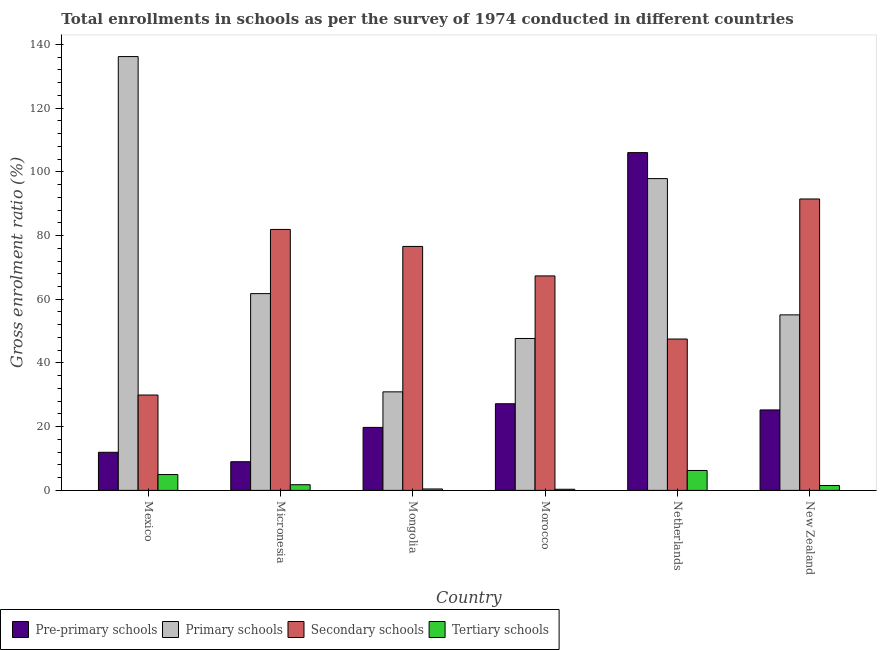How many groups of bars are there?
Keep it short and to the point. 6. Are the number of bars per tick equal to the number of legend labels?
Ensure brevity in your answer.  Yes. Are the number of bars on each tick of the X-axis equal?
Your answer should be compact. Yes. How many bars are there on the 1st tick from the right?
Give a very brief answer. 4. What is the label of the 4th group of bars from the left?
Ensure brevity in your answer.  Morocco. In how many cases, is the number of bars for a given country not equal to the number of legend labels?
Your answer should be compact. 0. What is the gross enrolment ratio in secondary schools in Morocco?
Ensure brevity in your answer.  67.33. Across all countries, what is the maximum gross enrolment ratio in pre-primary schools?
Provide a short and direct response. 106.03. Across all countries, what is the minimum gross enrolment ratio in pre-primary schools?
Make the answer very short. 9. In which country was the gross enrolment ratio in secondary schools minimum?
Your answer should be compact. Mexico. What is the total gross enrolment ratio in tertiary schools in the graph?
Provide a succinct answer. 15.34. What is the difference between the gross enrolment ratio in primary schools in Micronesia and that in Mongolia?
Ensure brevity in your answer.  30.83. What is the difference between the gross enrolment ratio in primary schools in Mexico and the gross enrolment ratio in secondary schools in New Zealand?
Offer a very short reply. 44.7. What is the average gross enrolment ratio in secondary schools per country?
Ensure brevity in your answer.  65.79. What is the difference between the gross enrolment ratio in pre-primary schools and gross enrolment ratio in secondary schools in New Zealand?
Your answer should be compact. -66.22. What is the ratio of the gross enrolment ratio in pre-primary schools in Mexico to that in Netherlands?
Offer a very short reply. 0.11. Is the gross enrolment ratio in secondary schools in Micronesia less than that in Mongolia?
Provide a succinct answer. No. What is the difference between the highest and the second highest gross enrolment ratio in primary schools?
Ensure brevity in your answer.  38.31. What is the difference between the highest and the lowest gross enrolment ratio in primary schools?
Offer a terse response. 105.24. In how many countries, is the gross enrolment ratio in primary schools greater than the average gross enrolment ratio in primary schools taken over all countries?
Provide a short and direct response. 2. Is it the case that in every country, the sum of the gross enrolment ratio in secondary schools and gross enrolment ratio in primary schools is greater than the sum of gross enrolment ratio in pre-primary schools and gross enrolment ratio in tertiary schools?
Make the answer very short. No. What does the 1st bar from the left in Netherlands represents?
Ensure brevity in your answer.  Pre-primary schools. What does the 3rd bar from the right in Mongolia represents?
Ensure brevity in your answer.  Primary schools. Is it the case that in every country, the sum of the gross enrolment ratio in pre-primary schools and gross enrolment ratio in primary schools is greater than the gross enrolment ratio in secondary schools?
Provide a short and direct response. No. How many countries are there in the graph?
Provide a short and direct response. 6. Are the values on the major ticks of Y-axis written in scientific E-notation?
Your response must be concise. No. Does the graph contain any zero values?
Keep it short and to the point. No. How many legend labels are there?
Offer a terse response. 4. How are the legend labels stacked?
Offer a very short reply. Horizontal. What is the title of the graph?
Give a very brief answer. Total enrollments in schools as per the survey of 1974 conducted in different countries. Does "Secondary" appear as one of the legend labels in the graph?
Make the answer very short. No. What is the label or title of the X-axis?
Your answer should be compact. Country. What is the label or title of the Y-axis?
Offer a very short reply. Gross enrolment ratio (%). What is the Gross enrolment ratio (%) of Pre-primary schools in Mexico?
Offer a very short reply. 11.96. What is the Gross enrolment ratio (%) of Primary schools in Mexico?
Provide a succinct answer. 136.18. What is the Gross enrolment ratio (%) in Secondary schools in Mexico?
Offer a terse response. 29.94. What is the Gross enrolment ratio (%) of Tertiary schools in Mexico?
Keep it short and to the point. 4.97. What is the Gross enrolment ratio (%) in Pre-primary schools in Micronesia?
Provide a succinct answer. 9. What is the Gross enrolment ratio (%) in Primary schools in Micronesia?
Offer a very short reply. 61.77. What is the Gross enrolment ratio (%) of Secondary schools in Micronesia?
Your answer should be very brief. 81.91. What is the Gross enrolment ratio (%) in Tertiary schools in Micronesia?
Provide a short and direct response. 1.78. What is the Gross enrolment ratio (%) of Pre-primary schools in Mongolia?
Ensure brevity in your answer.  19.77. What is the Gross enrolment ratio (%) in Primary schools in Mongolia?
Your answer should be very brief. 30.93. What is the Gross enrolment ratio (%) of Secondary schools in Mongolia?
Give a very brief answer. 76.58. What is the Gross enrolment ratio (%) in Tertiary schools in Mongolia?
Your answer should be compact. 0.45. What is the Gross enrolment ratio (%) in Pre-primary schools in Morocco?
Your answer should be compact. 27.2. What is the Gross enrolment ratio (%) of Primary schools in Morocco?
Keep it short and to the point. 47.68. What is the Gross enrolment ratio (%) in Secondary schools in Morocco?
Your answer should be compact. 67.33. What is the Gross enrolment ratio (%) of Tertiary schools in Morocco?
Provide a short and direct response. 0.35. What is the Gross enrolment ratio (%) of Pre-primary schools in Netherlands?
Offer a very short reply. 106.03. What is the Gross enrolment ratio (%) of Primary schools in Netherlands?
Give a very brief answer. 97.87. What is the Gross enrolment ratio (%) of Secondary schools in Netherlands?
Your response must be concise. 47.51. What is the Gross enrolment ratio (%) in Tertiary schools in Netherlands?
Give a very brief answer. 6.25. What is the Gross enrolment ratio (%) in Pre-primary schools in New Zealand?
Your answer should be very brief. 25.25. What is the Gross enrolment ratio (%) of Primary schools in New Zealand?
Provide a succinct answer. 55.09. What is the Gross enrolment ratio (%) in Secondary schools in New Zealand?
Offer a terse response. 91.47. What is the Gross enrolment ratio (%) of Tertiary schools in New Zealand?
Make the answer very short. 1.54. Across all countries, what is the maximum Gross enrolment ratio (%) of Pre-primary schools?
Your response must be concise. 106.03. Across all countries, what is the maximum Gross enrolment ratio (%) of Primary schools?
Make the answer very short. 136.18. Across all countries, what is the maximum Gross enrolment ratio (%) in Secondary schools?
Provide a short and direct response. 91.47. Across all countries, what is the maximum Gross enrolment ratio (%) of Tertiary schools?
Offer a very short reply. 6.25. Across all countries, what is the minimum Gross enrolment ratio (%) of Pre-primary schools?
Your answer should be very brief. 9. Across all countries, what is the minimum Gross enrolment ratio (%) of Primary schools?
Ensure brevity in your answer.  30.93. Across all countries, what is the minimum Gross enrolment ratio (%) of Secondary schools?
Give a very brief answer. 29.94. Across all countries, what is the minimum Gross enrolment ratio (%) of Tertiary schools?
Make the answer very short. 0.35. What is the total Gross enrolment ratio (%) in Pre-primary schools in the graph?
Offer a terse response. 199.2. What is the total Gross enrolment ratio (%) in Primary schools in the graph?
Provide a succinct answer. 429.53. What is the total Gross enrolment ratio (%) of Secondary schools in the graph?
Offer a very short reply. 394.75. What is the total Gross enrolment ratio (%) in Tertiary schools in the graph?
Ensure brevity in your answer.  15.34. What is the difference between the Gross enrolment ratio (%) of Pre-primary schools in Mexico and that in Micronesia?
Your response must be concise. 2.96. What is the difference between the Gross enrolment ratio (%) of Primary schools in Mexico and that in Micronesia?
Offer a very short reply. 74.41. What is the difference between the Gross enrolment ratio (%) of Secondary schools in Mexico and that in Micronesia?
Give a very brief answer. -51.98. What is the difference between the Gross enrolment ratio (%) of Tertiary schools in Mexico and that in Micronesia?
Provide a succinct answer. 3.19. What is the difference between the Gross enrolment ratio (%) of Pre-primary schools in Mexico and that in Mongolia?
Keep it short and to the point. -7.81. What is the difference between the Gross enrolment ratio (%) of Primary schools in Mexico and that in Mongolia?
Ensure brevity in your answer.  105.24. What is the difference between the Gross enrolment ratio (%) of Secondary schools in Mexico and that in Mongolia?
Your answer should be compact. -46.64. What is the difference between the Gross enrolment ratio (%) in Tertiary schools in Mexico and that in Mongolia?
Offer a very short reply. 4.53. What is the difference between the Gross enrolment ratio (%) in Pre-primary schools in Mexico and that in Morocco?
Give a very brief answer. -15.24. What is the difference between the Gross enrolment ratio (%) of Primary schools in Mexico and that in Morocco?
Your answer should be compact. 88.49. What is the difference between the Gross enrolment ratio (%) in Secondary schools in Mexico and that in Morocco?
Your response must be concise. -37.39. What is the difference between the Gross enrolment ratio (%) of Tertiary schools in Mexico and that in Morocco?
Make the answer very short. 4.62. What is the difference between the Gross enrolment ratio (%) of Pre-primary schools in Mexico and that in Netherlands?
Make the answer very short. -94.07. What is the difference between the Gross enrolment ratio (%) in Primary schools in Mexico and that in Netherlands?
Your answer should be very brief. 38.31. What is the difference between the Gross enrolment ratio (%) of Secondary schools in Mexico and that in Netherlands?
Offer a terse response. -17.58. What is the difference between the Gross enrolment ratio (%) of Tertiary schools in Mexico and that in Netherlands?
Give a very brief answer. -1.28. What is the difference between the Gross enrolment ratio (%) of Pre-primary schools in Mexico and that in New Zealand?
Give a very brief answer. -13.3. What is the difference between the Gross enrolment ratio (%) in Primary schools in Mexico and that in New Zealand?
Your answer should be compact. 81.08. What is the difference between the Gross enrolment ratio (%) of Secondary schools in Mexico and that in New Zealand?
Offer a terse response. -61.54. What is the difference between the Gross enrolment ratio (%) of Tertiary schools in Mexico and that in New Zealand?
Offer a very short reply. 3.44. What is the difference between the Gross enrolment ratio (%) in Pre-primary schools in Micronesia and that in Mongolia?
Make the answer very short. -10.77. What is the difference between the Gross enrolment ratio (%) in Primary schools in Micronesia and that in Mongolia?
Keep it short and to the point. 30.83. What is the difference between the Gross enrolment ratio (%) of Secondary schools in Micronesia and that in Mongolia?
Give a very brief answer. 5.33. What is the difference between the Gross enrolment ratio (%) in Tertiary schools in Micronesia and that in Mongolia?
Make the answer very short. 1.33. What is the difference between the Gross enrolment ratio (%) in Pre-primary schools in Micronesia and that in Morocco?
Your response must be concise. -18.2. What is the difference between the Gross enrolment ratio (%) in Primary schools in Micronesia and that in Morocco?
Your answer should be very brief. 14.08. What is the difference between the Gross enrolment ratio (%) of Secondary schools in Micronesia and that in Morocco?
Provide a succinct answer. 14.59. What is the difference between the Gross enrolment ratio (%) of Tertiary schools in Micronesia and that in Morocco?
Your answer should be compact. 1.43. What is the difference between the Gross enrolment ratio (%) in Pre-primary schools in Micronesia and that in Netherlands?
Provide a short and direct response. -97.03. What is the difference between the Gross enrolment ratio (%) of Primary schools in Micronesia and that in Netherlands?
Give a very brief answer. -36.1. What is the difference between the Gross enrolment ratio (%) in Secondary schools in Micronesia and that in Netherlands?
Offer a terse response. 34.4. What is the difference between the Gross enrolment ratio (%) of Tertiary schools in Micronesia and that in Netherlands?
Offer a very short reply. -4.47. What is the difference between the Gross enrolment ratio (%) of Pre-primary schools in Micronesia and that in New Zealand?
Offer a terse response. -16.25. What is the difference between the Gross enrolment ratio (%) in Primary schools in Micronesia and that in New Zealand?
Keep it short and to the point. 6.67. What is the difference between the Gross enrolment ratio (%) of Secondary schools in Micronesia and that in New Zealand?
Offer a very short reply. -9.56. What is the difference between the Gross enrolment ratio (%) of Tertiary schools in Micronesia and that in New Zealand?
Ensure brevity in your answer.  0.24. What is the difference between the Gross enrolment ratio (%) of Pre-primary schools in Mongolia and that in Morocco?
Give a very brief answer. -7.42. What is the difference between the Gross enrolment ratio (%) in Primary schools in Mongolia and that in Morocco?
Make the answer very short. -16.75. What is the difference between the Gross enrolment ratio (%) of Secondary schools in Mongolia and that in Morocco?
Offer a terse response. 9.26. What is the difference between the Gross enrolment ratio (%) of Tertiary schools in Mongolia and that in Morocco?
Provide a short and direct response. 0.09. What is the difference between the Gross enrolment ratio (%) of Pre-primary schools in Mongolia and that in Netherlands?
Offer a terse response. -86.26. What is the difference between the Gross enrolment ratio (%) in Primary schools in Mongolia and that in Netherlands?
Provide a short and direct response. -66.94. What is the difference between the Gross enrolment ratio (%) in Secondary schools in Mongolia and that in Netherlands?
Provide a succinct answer. 29.07. What is the difference between the Gross enrolment ratio (%) of Tertiary schools in Mongolia and that in Netherlands?
Give a very brief answer. -5.8. What is the difference between the Gross enrolment ratio (%) in Pre-primary schools in Mongolia and that in New Zealand?
Make the answer very short. -5.48. What is the difference between the Gross enrolment ratio (%) of Primary schools in Mongolia and that in New Zealand?
Your answer should be compact. -24.16. What is the difference between the Gross enrolment ratio (%) in Secondary schools in Mongolia and that in New Zealand?
Offer a very short reply. -14.89. What is the difference between the Gross enrolment ratio (%) of Tertiary schools in Mongolia and that in New Zealand?
Give a very brief answer. -1.09. What is the difference between the Gross enrolment ratio (%) of Pre-primary schools in Morocco and that in Netherlands?
Your answer should be very brief. -78.83. What is the difference between the Gross enrolment ratio (%) of Primary schools in Morocco and that in Netherlands?
Provide a short and direct response. -50.18. What is the difference between the Gross enrolment ratio (%) of Secondary schools in Morocco and that in Netherlands?
Your answer should be very brief. 19.81. What is the difference between the Gross enrolment ratio (%) of Tertiary schools in Morocco and that in Netherlands?
Give a very brief answer. -5.9. What is the difference between the Gross enrolment ratio (%) in Pre-primary schools in Morocco and that in New Zealand?
Provide a succinct answer. 1.94. What is the difference between the Gross enrolment ratio (%) of Primary schools in Morocco and that in New Zealand?
Provide a succinct answer. -7.41. What is the difference between the Gross enrolment ratio (%) of Secondary schools in Morocco and that in New Zealand?
Keep it short and to the point. -24.15. What is the difference between the Gross enrolment ratio (%) in Tertiary schools in Morocco and that in New Zealand?
Make the answer very short. -1.18. What is the difference between the Gross enrolment ratio (%) of Pre-primary schools in Netherlands and that in New Zealand?
Give a very brief answer. 80.77. What is the difference between the Gross enrolment ratio (%) in Primary schools in Netherlands and that in New Zealand?
Provide a succinct answer. 42.77. What is the difference between the Gross enrolment ratio (%) of Secondary schools in Netherlands and that in New Zealand?
Give a very brief answer. -43.96. What is the difference between the Gross enrolment ratio (%) in Tertiary schools in Netherlands and that in New Zealand?
Offer a terse response. 4.71. What is the difference between the Gross enrolment ratio (%) of Pre-primary schools in Mexico and the Gross enrolment ratio (%) of Primary schools in Micronesia?
Your response must be concise. -49.81. What is the difference between the Gross enrolment ratio (%) of Pre-primary schools in Mexico and the Gross enrolment ratio (%) of Secondary schools in Micronesia?
Make the answer very short. -69.96. What is the difference between the Gross enrolment ratio (%) in Pre-primary schools in Mexico and the Gross enrolment ratio (%) in Tertiary schools in Micronesia?
Offer a very short reply. 10.18. What is the difference between the Gross enrolment ratio (%) of Primary schools in Mexico and the Gross enrolment ratio (%) of Secondary schools in Micronesia?
Make the answer very short. 54.26. What is the difference between the Gross enrolment ratio (%) of Primary schools in Mexico and the Gross enrolment ratio (%) of Tertiary schools in Micronesia?
Your answer should be compact. 134.4. What is the difference between the Gross enrolment ratio (%) of Secondary schools in Mexico and the Gross enrolment ratio (%) of Tertiary schools in Micronesia?
Provide a succinct answer. 28.16. What is the difference between the Gross enrolment ratio (%) in Pre-primary schools in Mexico and the Gross enrolment ratio (%) in Primary schools in Mongolia?
Keep it short and to the point. -18.98. What is the difference between the Gross enrolment ratio (%) of Pre-primary schools in Mexico and the Gross enrolment ratio (%) of Secondary schools in Mongolia?
Your answer should be compact. -64.62. What is the difference between the Gross enrolment ratio (%) in Pre-primary schools in Mexico and the Gross enrolment ratio (%) in Tertiary schools in Mongolia?
Your answer should be very brief. 11.51. What is the difference between the Gross enrolment ratio (%) in Primary schools in Mexico and the Gross enrolment ratio (%) in Secondary schools in Mongolia?
Keep it short and to the point. 59.6. What is the difference between the Gross enrolment ratio (%) in Primary schools in Mexico and the Gross enrolment ratio (%) in Tertiary schools in Mongolia?
Ensure brevity in your answer.  135.73. What is the difference between the Gross enrolment ratio (%) of Secondary schools in Mexico and the Gross enrolment ratio (%) of Tertiary schools in Mongolia?
Provide a short and direct response. 29.49. What is the difference between the Gross enrolment ratio (%) of Pre-primary schools in Mexico and the Gross enrolment ratio (%) of Primary schools in Morocco?
Provide a short and direct response. -35.73. What is the difference between the Gross enrolment ratio (%) of Pre-primary schools in Mexico and the Gross enrolment ratio (%) of Secondary schools in Morocco?
Your answer should be very brief. -55.37. What is the difference between the Gross enrolment ratio (%) in Pre-primary schools in Mexico and the Gross enrolment ratio (%) in Tertiary schools in Morocco?
Your answer should be very brief. 11.6. What is the difference between the Gross enrolment ratio (%) of Primary schools in Mexico and the Gross enrolment ratio (%) of Secondary schools in Morocco?
Offer a terse response. 68.85. What is the difference between the Gross enrolment ratio (%) of Primary schools in Mexico and the Gross enrolment ratio (%) of Tertiary schools in Morocco?
Keep it short and to the point. 135.83. What is the difference between the Gross enrolment ratio (%) in Secondary schools in Mexico and the Gross enrolment ratio (%) in Tertiary schools in Morocco?
Provide a succinct answer. 29.58. What is the difference between the Gross enrolment ratio (%) in Pre-primary schools in Mexico and the Gross enrolment ratio (%) in Primary schools in Netherlands?
Ensure brevity in your answer.  -85.91. What is the difference between the Gross enrolment ratio (%) of Pre-primary schools in Mexico and the Gross enrolment ratio (%) of Secondary schools in Netherlands?
Make the answer very short. -35.56. What is the difference between the Gross enrolment ratio (%) of Pre-primary schools in Mexico and the Gross enrolment ratio (%) of Tertiary schools in Netherlands?
Provide a succinct answer. 5.71. What is the difference between the Gross enrolment ratio (%) in Primary schools in Mexico and the Gross enrolment ratio (%) in Secondary schools in Netherlands?
Your answer should be very brief. 88.66. What is the difference between the Gross enrolment ratio (%) of Primary schools in Mexico and the Gross enrolment ratio (%) of Tertiary schools in Netherlands?
Make the answer very short. 129.93. What is the difference between the Gross enrolment ratio (%) of Secondary schools in Mexico and the Gross enrolment ratio (%) of Tertiary schools in Netherlands?
Your answer should be compact. 23.69. What is the difference between the Gross enrolment ratio (%) in Pre-primary schools in Mexico and the Gross enrolment ratio (%) in Primary schools in New Zealand?
Your answer should be compact. -43.14. What is the difference between the Gross enrolment ratio (%) of Pre-primary schools in Mexico and the Gross enrolment ratio (%) of Secondary schools in New Zealand?
Your response must be concise. -79.52. What is the difference between the Gross enrolment ratio (%) in Pre-primary schools in Mexico and the Gross enrolment ratio (%) in Tertiary schools in New Zealand?
Ensure brevity in your answer.  10.42. What is the difference between the Gross enrolment ratio (%) of Primary schools in Mexico and the Gross enrolment ratio (%) of Secondary schools in New Zealand?
Ensure brevity in your answer.  44.7. What is the difference between the Gross enrolment ratio (%) in Primary schools in Mexico and the Gross enrolment ratio (%) in Tertiary schools in New Zealand?
Make the answer very short. 134.64. What is the difference between the Gross enrolment ratio (%) in Secondary schools in Mexico and the Gross enrolment ratio (%) in Tertiary schools in New Zealand?
Offer a terse response. 28.4. What is the difference between the Gross enrolment ratio (%) of Pre-primary schools in Micronesia and the Gross enrolment ratio (%) of Primary schools in Mongolia?
Provide a short and direct response. -21.93. What is the difference between the Gross enrolment ratio (%) of Pre-primary schools in Micronesia and the Gross enrolment ratio (%) of Secondary schools in Mongolia?
Your answer should be compact. -67.58. What is the difference between the Gross enrolment ratio (%) of Pre-primary schools in Micronesia and the Gross enrolment ratio (%) of Tertiary schools in Mongolia?
Offer a very short reply. 8.55. What is the difference between the Gross enrolment ratio (%) of Primary schools in Micronesia and the Gross enrolment ratio (%) of Secondary schools in Mongolia?
Your answer should be very brief. -14.82. What is the difference between the Gross enrolment ratio (%) of Primary schools in Micronesia and the Gross enrolment ratio (%) of Tertiary schools in Mongolia?
Your answer should be compact. 61.32. What is the difference between the Gross enrolment ratio (%) of Secondary schools in Micronesia and the Gross enrolment ratio (%) of Tertiary schools in Mongolia?
Your answer should be very brief. 81.47. What is the difference between the Gross enrolment ratio (%) of Pre-primary schools in Micronesia and the Gross enrolment ratio (%) of Primary schools in Morocco?
Offer a very short reply. -38.69. What is the difference between the Gross enrolment ratio (%) in Pre-primary schools in Micronesia and the Gross enrolment ratio (%) in Secondary schools in Morocco?
Offer a very short reply. -58.33. What is the difference between the Gross enrolment ratio (%) in Pre-primary schools in Micronesia and the Gross enrolment ratio (%) in Tertiary schools in Morocco?
Make the answer very short. 8.65. What is the difference between the Gross enrolment ratio (%) in Primary schools in Micronesia and the Gross enrolment ratio (%) in Secondary schools in Morocco?
Give a very brief answer. -5.56. What is the difference between the Gross enrolment ratio (%) in Primary schools in Micronesia and the Gross enrolment ratio (%) in Tertiary schools in Morocco?
Keep it short and to the point. 61.41. What is the difference between the Gross enrolment ratio (%) of Secondary schools in Micronesia and the Gross enrolment ratio (%) of Tertiary schools in Morocco?
Offer a terse response. 81.56. What is the difference between the Gross enrolment ratio (%) in Pre-primary schools in Micronesia and the Gross enrolment ratio (%) in Primary schools in Netherlands?
Make the answer very short. -88.87. What is the difference between the Gross enrolment ratio (%) of Pre-primary schools in Micronesia and the Gross enrolment ratio (%) of Secondary schools in Netherlands?
Make the answer very short. -38.51. What is the difference between the Gross enrolment ratio (%) in Pre-primary schools in Micronesia and the Gross enrolment ratio (%) in Tertiary schools in Netherlands?
Give a very brief answer. 2.75. What is the difference between the Gross enrolment ratio (%) in Primary schools in Micronesia and the Gross enrolment ratio (%) in Secondary schools in Netherlands?
Your answer should be compact. 14.25. What is the difference between the Gross enrolment ratio (%) in Primary schools in Micronesia and the Gross enrolment ratio (%) in Tertiary schools in Netherlands?
Your answer should be compact. 55.51. What is the difference between the Gross enrolment ratio (%) of Secondary schools in Micronesia and the Gross enrolment ratio (%) of Tertiary schools in Netherlands?
Offer a very short reply. 75.66. What is the difference between the Gross enrolment ratio (%) in Pre-primary schools in Micronesia and the Gross enrolment ratio (%) in Primary schools in New Zealand?
Give a very brief answer. -46.1. What is the difference between the Gross enrolment ratio (%) of Pre-primary schools in Micronesia and the Gross enrolment ratio (%) of Secondary schools in New Zealand?
Provide a short and direct response. -82.47. What is the difference between the Gross enrolment ratio (%) of Pre-primary schools in Micronesia and the Gross enrolment ratio (%) of Tertiary schools in New Zealand?
Ensure brevity in your answer.  7.46. What is the difference between the Gross enrolment ratio (%) in Primary schools in Micronesia and the Gross enrolment ratio (%) in Secondary schools in New Zealand?
Your response must be concise. -29.71. What is the difference between the Gross enrolment ratio (%) of Primary schools in Micronesia and the Gross enrolment ratio (%) of Tertiary schools in New Zealand?
Provide a short and direct response. 60.23. What is the difference between the Gross enrolment ratio (%) in Secondary schools in Micronesia and the Gross enrolment ratio (%) in Tertiary schools in New Zealand?
Give a very brief answer. 80.38. What is the difference between the Gross enrolment ratio (%) in Pre-primary schools in Mongolia and the Gross enrolment ratio (%) in Primary schools in Morocco?
Provide a short and direct response. -27.91. What is the difference between the Gross enrolment ratio (%) of Pre-primary schools in Mongolia and the Gross enrolment ratio (%) of Secondary schools in Morocco?
Your answer should be very brief. -47.55. What is the difference between the Gross enrolment ratio (%) in Pre-primary schools in Mongolia and the Gross enrolment ratio (%) in Tertiary schools in Morocco?
Your answer should be compact. 19.42. What is the difference between the Gross enrolment ratio (%) of Primary schools in Mongolia and the Gross enrolment ratio (%) of Secondary schools in Morocco?
Offer a very short reply. -36.39. What is the difference between the Gross enrolment ratio (%) in Primary schools in Mongolia and the Gross enrolment ratio (%) in Tertiary schools in Morocco?
Offer a terse response. 30.58. What is the difference between the Gross enrolment ratio (%) in Secondary schools in Mongolia and the Gross enrolment ratio (%) in Tertiary schools in Morocco?
Give a very brief answer. 76.23. What is the difference between the Gross enrolment ratio (%) of Pre-primary schools in Mongolia and the Gross enrolment ratio (%) of Primary schools in Netherlands?
Your answer should be compact. -78.1. What is the difference between the Gross enrolment ratio (%) of Pre-primary schools in Mongolia and the Gross enrolment ratio (%) of Secondary schools in Netherlands?
Offer a terse response. -27.74. What is the difference between the Gross enrolment ratio (%) in Pre-primary schools in Mongolia and the Gross enrolment ratio (%) in Tertiary schools in Netherlands?
Offer a very short reply. 13.52. What is the difference between the Gross enrolment ratio (%) of Primary schools in Mongolia and the Gross enrolment ratio (%) of Secondary schools in Netherlands?
Provide a succinct answer. -16.58. What is the difference between the Gross enrolment ratio (%) in Primary schools in Mongolia and the Gross enrolment ratio (%) in Tertiary schools in Netherlands?
Provide a short and direct response. 24.68. What is the difference between the Gross enrolment ratio (%) of Secondary schools in Mongolia and the Gross enrolment ratio (%) of Tertiary schools in Netherlands?
Your answer should be compact. 70.33. What is the difference between the Gross enrolment ratio (%) of Pre-primary schools in Mongolia and the Gross enrolment ratio (%) of Primary schools in New Zealand?
Your answer should be very brief. -35.32. What is the difference between the Gross enrolment ratio (%) in Pre-primary schools in Mongolia and the Gross enrolment ratio (%) in Secondary schools in New Zealand?
Your answer should be very brief. -71.7. What is the difference between the Gross enrolment ratio (%) of Pre-primary schools in Mongolia and the Gross enrolment ratio (%) of Tertiary schools in New Zealand?
Ensure brevity in your answer.  18.23. What is the difference between the Gross enrolment ratio (%) of Primary schools in Mongolia and the Gross enrolment ratio (%) of Secondary schools in New Zealand?
Give a very brief answer. -60.54. What is the difference between the Gross enrolment ratio (%) in Primary schools in Mongolia and the Gross enrolment ratio (%) in Tertiary schools in New Zealand?
Your answer should be very brief. 29.4. What is the difference between the Gross enrolment ratio (%) in Secondary schools in Mongolia and the Gross enrolment ratio (%) in Tertiary schools in New Zealand?
Offer a terse response. 75.04. What is the difference between the Gross enrolment ratio (%) in Pre-primary schools in Morocco and the Gross enrolment ratio (%) in Primary schools in Netherlands?
Provide a succinct answer. -70.67. What is the difference between the Gross enrolment ratio (%) of Pre-primary schools in Morocco and the Gross enrolment ratio (%) of Secondary schools in Netherlands?
Make the answer very short. -20.32. What is the difference between the Gross enrolment ratio (%) in Pre-primary schools in Morocco and the Gross enrolment ratio (%) in Tertiary schools in Netherlands?
Make the answer very short. 20.94. What is the difference between the Gross enrolment ratio (%) of Primary schools in Morocco and the Gross enrolment ratio (%) of Secondary schools in Netherlands?
Offer a terse response. 0.17. What is the difference between the Gross enrolment ratio (%) in Primary schools in Morocco and the Gross enrolment ratio (%) in Tertiary schools in Netherlands?
Offer a terse response. 41.43. What is the difference between the Gross enrolment ratio (%) in Secondary schools in Morocco and the Gross enrolment ratio (%) in Tertiary schools in Netherlands?
Give a very brief answer. 61.07. What is the difference between the Gross enrolment ratio (%) of Pre-primary schools in Morocco and the Gross enrolment ratio (%) of Primary schools in New Zealand?
Give a very brief answer. -27.9. What is the difference between the Gross enrolment ratio (%) in Pre-primary schools in Morocco and the Gross enrolment ratio (%) in Secondary schools in New Zealand?
Keep it short and to the point. -64.28. What is the difference between the Gross enrolment ratio (%) in Pre-primary schools in Morocco and the Gross enrolment ratio (%) in Tertiary schools in New Zealand?
Your response must be concise. 25.66. What is the difference between the Gross enrolment ratio (%) in Primary schools in Morocco and the Gross enrolment ratio (%) in Secondary schools in New Zealand?
Keep it short and to the point. -43.79. What is the difference between the Gross enrolment ratio (%) of Primary schools in Morocco and the Gross enrolment ratio (%) of Tertiary schools in New Zealand?
Provide a short and direct response. 46.15. What is the difference between the Gross enrolment ratio (%) in Secondary schools in Morocco and the Gross enrolment ratio (%) in Tertiary schools in New Zealand?
Your answer should be very brief. 65.79. What is the difference between the Gross enrolment ratio (%) in Pre-primary schools in Netherlands and the Gross enrolment ratio (%) in Primary schools in New Zealand?
Ensure brevity in your answer.  50.93. What is the difference between the Gross enrolment ratio (%) in Pre-primary schools in Netherlands and the Gross enrolment ratio (%) in Secondary schools in New Zealand?
Give a very brief answer. 14.55. What is the difference between the Gross enrolment ratio (%) of Pre-primary schools in Netherlands and the Gross enrolment ratio (%) of Tertiary schools in New Zealand?
Ensure brevity in your answer.  104.49. What is the difference between the Gross enrolment ratio (%) of Primary schools in Netherlands and the Gross enrolment ratio (%) of Secondary schools in New Zealand?
Provide a succinct answer. 6.4. What is the difference between the Gross enrolment ratio (%) of Primary schools in Netherlands and the Gross enrolment ratio (%) of Tertiary schools in New Zealand?
Provide a short and direct response. 96.33. What is the difference between the Gross enrolment ratio (%) in Secondary schools in Netherlands and the Gross enrolment ratio (%) in Tertiary schools in New Zealand?
Ensure brevity in your answer.  45.98. What is the average Gross enrolment ratio (%) in Pre-primary schools per country?
Give a very brief answer. 33.2. What is the average Gross enrolment ratio (%) of Primary schools per country?
Keep it short and to the point. 71.59. What is the average Gross enrolment ratio (%) in Secondary schools per country?
Your answer should be very brief. 65.79. What is the average Gross enrolment ratio (%) in Tertiary schools per country?
Provide a succinct answer. 2.56. What is the difference between the Gross enrolment ratio (%) of Pre-primary schools and Gross enrolment ratio (%) of Primary schools in Mexico?
Give a very brief answer. -124.22. What is the difference between the Gross enrolment ratio (%) of Pre-primary schools and Gross enrolment ratio (%) of Secondary schools in Mexico?
Provide a succinct answer. -17.98. What is the difference between the Gross enrolment ratio (%) of Pre-primary schools and Gross enrolment ratio (%) of Tertiary schools in Mexico?
Ensure brevity in your answer.  6.98. What is the difference between the Gross enrolment ratio (%) in Primary schools and Gross enrolment ratio (%) in Secondary schools in Mexico?
Make the answer very short. 106.24. What is the difference between the Gross enrolment ratio (%) in Primary schools and Gross enrolment ratio (%) in Tertiary schools in Mexico?
Give a very brief answer. 131.21. What is the difference between the Gross enrolment ratio (%) in Secondary schools and Gross enrolment ratio (%) in Tertiary schools in Mexico?
Keep it short and to the point. 24.96. What is the difference between the Gross enrolment ratio (%) in Pre-primary schools and Gross enrolment ratio (%) in Primary schools in Micronesia?
Provide a short and direct response. -52.77. What is the difference between the Gross enrolment ratio (%) of Pre-primary schools and Gross enrolment ratio (%) of Secondary schools in Micronesia?
Provide a short and direct response. -72.92. What is the difference between the Gross enrolment ratio (%) of Pre-primary schools and Gross enrolment ratio (%) of Tertiary schools in Micronesia?
Offer a very short reply. 7.22. What is the difference between the Gross enrolment ratio (%) in Primary schools and Gross enrolment ratio (%) in Secondary schools in Micronesia?
Your answer should be compact. -20.15. What is the difference between the Gross enrolment ratio (%) of Primary schools and Gross enrolment ratio (%) of Tertiary schools in Micronesia?
Make the answer very short. 59.98. What is the difference between the Gross enrolment ratio (%) in Secondary schools and Gross enrolment ratio (%) in Tertiary schools in Micronesia?
Offer a terse response. 80.13. What is the difference between the Gross enrolment ratio (%) in Pre-primary schools and Gross enrolment ratio (%) in Primary schools in Mongolia?
Give a very brief answer. -11.16. What is the difference between the Gross enrolment ratio (%) of Pre-primary schools and Gross enrolment ratio (%) of Secondary schools in Mongolia?
Provide a succinct answer. -56.81. What is the difference between the Gross enrolment ratio (%) in Pre-primary schools and Gross enrolment ratio (%) in Tertiary schools in Mongolia?
Give a very brief answer. 19.32. What is the difference between the Gross enrolment ratio (%) in Primary schools and Gross enrolment ratio (%) in Secondary schools in Mongolia?
Provide a short and direct response. -45.65. What is the difference between the Gross enrolment ratio (%) of Primary schools and Gross enrolment ratio (%) of Tertiary schools in Mongolia?
Provide a short and direct response. 30.49. What is the difference between the Gross enrolment ratio (%) of Secondary schools and Gross enrolment ratio (%) of Tertiary schools in Mongolia?
Ensure brevity in your answer.  76.13. What is the difference between the Gross enrolment ratio (%) in Pre-primary schools and Gross enrolment ratio (%) in Primary schools in Morocco?
Make the answer very short. -20.49. What is the difference between the Gross enrolment ratio (%) of Pre-primary schools and Gross enrolment ratio (%) of Secondary schools in Morocco?
Your answer should be very brief. -40.13. What is the difference between the Gross enrolment ratio (%) of Pre-primary schools and Gross enrolment ratio (%) of Tertiary schools in Morocco?
Provide a short and direct response. 26.84. What is the difference between the Gross enrolment ratio (%) of Primary schools and Gross enrolment ratio (%) of Secondary schools in Morocco?
Your answer should be compact. -19.64. What is the difference between the Gross enrolment ratio (%) of Primary schools and Gross enrolment ratio (%) of Tertiary schools in Morocco?
Provide a succinct answer. 47.33. What is the difference between the Gross enrolment ratio (%) in Secondary schools and Gross enrolment ratio (%) in Tertiary schools in Morocco?
Your response must be concise. 66.97. What is the difference between the Gross enrolment ratio (%) in Pre-primary schools and Gross enrolment ratio (%) in Primary schools in Netherlands?
Your answer should be very brief. 8.16. What is the difference between the Gross enrolment ratio (%) of Pre-primary schools and Gross enrolment ratio (%) of Secondary schools in Netherlands?
Keep it short and to the point. 58.51. What is the difference between the Gross enrolment ratio (%) in Pre-primary schools and Gross enrolment ratio (%) in Tertiary schools in Netherlands?
Your response must be concise. 99.78. What is the difference between the Gross enrolment ratio (%) in Primary schools and Gross enrolment ratio (%) in Secondary schools in Netherlands?
Keep it short and to the point. 50.36. What is the difference between the Gross enrolment ratio (%) in Primary schools and Gross enrolment ratio (%) in Tertiary schools in Netherlands?
Your answer should be compact. 91.62. What is the difference between the Gross enrolment ratio (%) of Secondary schools and Gross enrolment ratio (%) of Tertiary schools in Netherlands?
Provide a succinct answer. 41.26. What is the difference between the Gross enrolment ratio (%) of Pre-primary schools and Gross enrolment ratio (%) of Primary schools in New Zealand?
Your answer should be compact. -29.84. What is the difference between the Gross enrolment ratio (%) in Pre-primary schools and Gross enrolment ratio (%) in Secondary schools in New Zealand?
Give a very brief answer. -66.22. What is the difference between the Gross enrolment ratio (%) of Pre-primary schools and Gross enrolment ratio (%) of Tertiary schools in New Zealand?
Give a very brief answer. 23.72. What is the difference between the Gross enrolment ratio (%) of Primary schools and Gross enrolment ratio (%) of Secondary schools in New Zealand?
Ensure brevity in your answer.  -36.38. What is the difference between the Gross enrolment ratio (%) of Primary schools and Gross enrolment ratio (%) of Tertiary schools in New Zealand?
Keep it short and to the point. 53.56. What is the difference between the Gross enrolment ratio (%) of Secondary schools and Gross enrolment ratio (%) of Tertiary schools in New Zealand?
Your answer should be very brief. 89.94. What is the ratio of the Gross enrolment ratio (%) of Pre-primary schools in Mexico to that in Micronesia?
Your answer should be compact. 1.33. What is the ratio of the Gross enrolment ratio (%) of Primary schools in Mexico to that in Micronesia?
Give a very brief answer. 2.2. What is the ratio of the Gross enrolment ratio (%) in Secondary schools in Mexico to that in Micronesia?
Make the answer very short. 0.37. What is the ratio of the Gross enrolment ratio (%) of Tertiary schools in Mexico to that in Micronesia?
Offer a terse response. 2.79. What is the ratio of the Gross enrolment ratio (%) of Pre-primary schools in Mexico to that in Mongolia?
Keep it short and to the point. 0.6. What is the ratio of the Gross enrolment ratio (%) of Primary schools in Mexico to that in Mongolia?
Provide a succinct answer. 4.4. What is the ratio of the Gross enrolment ratio (%) in Secondary schools in Mexico to that in Mongolia?
Offer a terse response. 0.39. What is the ratio of the Gross enrolment ratio (%) of Tertiary schools in Mexico to that in Mongolia?
Offer a terse response. 11.1. What is the ratio of the Gross enrolment ratio (%) of Pre-primary schools in Mexico to that in Morocco?
Ensure brevity in your answer.  0.44. What is the ratio of the Gross enrolment ratio (%) in Primary schools in Mexico to that in Morocco?
Give a very brief answer. 2.86. What is the ratio of the Gross enrolment ratio (%) in Secondary schools in Mexico to that in Morocco?
Your answer should be very brief. 0.44. What is the ratio of the Gross enrolment ratio (%) in Tertiary schools in Mexico to that in Morocco?
Make the answer very short. 14.08. What is the ratio of the Gross enrolment ratio (%) of Pre-primary schools in Mexico to that in Netherlands?
Make the answer very short. 0.11. What is the ratio of the Gross enrolment ratio (%) in Primary schools in Mexico to that in Netherlands?
Ensure brevity in your answer.  1.39. What is the ratio of the Gross enrolment ratio (%) in Secondary schools in Mexico to that in Netherlands?
Offer a terse response. 0.63. What is the ratio of the Gross enrolment ratio (%) of Tertiary schools in Mexico to that in Netherlands?
Ensure brevity in your answer.  0.8. What is the ratio of the Gross enrolment ratio (%) of Pre-primary schools in Mexico to that in New Zealand?
Offer a very short reply. 0.47. What is the ratio of the Gross enrolment ratio (%) of Primary schools in Mexico to that in New Zealand?
Your answer should be compact. 2.47. What is the ratio of the Gross enrolment ratio (%) of Secondary schools in Mexico to that in New Zealand?
Ensure brevity in your answer.  0.33. What is the ratio of the Gross enrolment ratio (%) of Tertiary schools in Mexico to that in New Zealand?
Ensure brevity in your answer.  3.23. What is the ratio of the Gross enrolment ratio (%) in Pre-primary schools in Micronesia to that in Mongolia?
Provide a succinct answer. 0.46. What is the ratio of the Gross enrolment ratio (%) of Primary schools in Micronesia to that in Mongolia?
Offer a terse response. 2. What is the ratio of the Gross enrolment ratio (%) of Secondary schools in Micronesia to that in Mongolia?
Provide a succinct answer. 1.07. What is the ratio of the Gross enrolment ratio (%) in Tertiary schools in Micronesia to that in Mongolia?
Your response must be concise. 3.97. What is the ratio of the Gross enrolment ratio (%) in Pre-primary schools in Micronesia to that in Morocco?
Ensure brevity in your answer.  0.33. What is the ratio of the Gross enrolment ratio (%) of Primary schools in Micronesia to that in Morocco?
Give a very brief answer. 1.3. What is the ratio of the Gross enrolment ratio (%) of Secondary schools in Micronesia to that in Morocco?
Provide a succinct answer. 1.22. What is the ratio of the Gross enrolment ratio (%) of Tertiary schools in Micronesia to that in Morocco?
Offer a terse response. 5.04. What is the ratio of the Gross enrolment ratio (%) in Pre-primary schools in Micronesia to that in Netherlands?
Your response must be concise. 0.08. What is the ratio of the Gross enrolment ratio (%) of Primary schools in Micronesia to that in Netherlands?
Offer a terse response. 0.63. What is the ratio of the Gross enrolment ratio (%) of Secondary schools in Micronesia to that in Netherlands?
Give a very brief answer. 1.72. What is the ratio of the Gross enrolment ratio (%) in Tertiary schools in Micronesia to that in Netherlands?
Provide a short and direct response. 0.28. What is the ratio of the Gross enrolment ratio (%) of Pre-primary schools in Micronesia to that in New Zealand?
Ensure brevity in your answer.  0.36. What is the ratio of the Gross enrolment ratio (%) of Primary schools in Micronesia to that in New Zealand?
Make the answer very short. 1.12. What is the ratio of the Gross enrolment ratio (%) of Secondary schools in Micronesia to that in New Zealand?
Ensure brevity in your answer.  0.9. What is the ratio of the Gross enrolment ratio (%) of Tertiary schools in Micronesia to that in New Zealand?
Offer a terse response. 1.16. What is the ratio of the Gross enrolment ratio (%) in Pre-primary schools in Mongolia to that in Morocco?
Keep it short and to the point. 0.73. What is the ratio of the Gross enrolment ratio (%) in Primary schools in Mongolia to that in Morocco?
Provide a short and direct response. 0.65. What is the ratio of the Gross enrolment ratio (%) of Secondary schools in Mongolia to that in Morocco?
Provide a short and direct response. 1.14. What is the ratio of the Gross enrolment ratio (%) in Tertiary schools in Mongolia to that in Morocco?
Make the answer very short. 1.27. What is the ratio of the Gross enrolment ratio (%) in Pre-primary schools in Mongolia to that in Netherlands?
Keep it short and to the point. 0.19. What is the ratio of the Gross enrolment ratio (%) in Primary schools in Mongolia to that in Netherlands?
Provide a succinct answer. 0.32. What is the ratio of the Gross enrolment ratio (%) in Secondary schools in Mongolia to that in Netherlands?
Offer a terse response. 1.61. What is the ratio of the Gross enrolment ratio (%) in Tertiary schools in Mongolia to that in Netherlands?
Keep it short and to the point. 0.07. What is the ratio of the Gross enrolment ratio (%) of Pre-primary schools in Mongolia to that in New Zealand?
Your answer should be very brief. 0.78. What is the ratio of the Gross enrolment ratio (%) in Primary schools in Mongolia to that in New Zealand?
Keep it short and to the point. 0.56. What is the ratio of the Gross enrolment ratio (%) of Secondary schools in Mongolia to that in New Zealand?
Make the answer very short. 0.84. What is the ratio of the Gross enrolment ratio (%) in Tertiary schools in Mongolia to that in New Zealand?
Offer a terse response. 0.29. What is the ratio of the Gross enrolment ratio (%) in Pre-primary schools in Morocco to that in Netherlands?
Give a very brief answer. 0.26. What is the ratio of the Gross enrolment ratio (%) of Primary schools in Morocco to that in Netherlands?
Provide a short and direct response. 0.49. What is the ratio of the Gross enrolment ratio (%) of Secondary schools in Morocco to that in Netherlands?
Your response must be concise. 1.42. What is the ratio of the Gross enrolment ratio (%) of Tertiary schools in Morocco to that in Netherlands?
Offer a very short reply. 0.06. What is the ratio of the Gross enrolment ratio (%) in Pre-primary schools in Morocco to that in New Zealand?
Your answer should be compact. 1.08. What is the ratio of the Gross enrolment ratio (%) of Primary schools in Morocco to that in New Zealand?
Your answer should be compact. 0.87. What is the ratio of the Gross enrolment ratio (%) in Secondary schools in Morocco to that in New Zealand?
Offer a very short reply. 0.74. What is the ratio of the Gross enrolment ratio (%) of Tertiary schools in Morocco to that in New Zealand?
Your answer should be very brief. 0.23. What is the ratio of the Gross enrolment ratio (%) in Pre-primary schools in Netherlands to that in New Zealand?
Offer a terse response. 4.2. What is the ratio of the Gross enrolment ratio (%) in Primary schools in Netherlands to that in New Zealand?
Give a very brief answer. 1.78. What is the ratio of the Gross enrolment ratio (%) in Secondary schools in Netherlands to that in New Zealand?
Provide a succinct answer. 0.52. What is the ratio of the Gross enrolment ratio (%) of Tertiary schools in Netherlands to that in New Zealand?
Offer a very short reply. 4.07. What is the difference between the highest and the second highest Gross enrolment ratio (%) of Pre-primary schools?
Provide a succinct answer. 78.83. What is the difference between the highest and the second highest Gross enrolment ratio (%) in Primary schools?
Give a very brief answer. 38.31. What is the difference between the highest and the second highest Gross enrolment ratio (%) of Secondary schools?
Provide a short and direct response. 9.56. What is the difference between the highest and the second highest Gross enrolment ratio (%) of Tertiary schools?
Offer a terse response. 1.28. What is the difference between the highest and the lowest Gross enrolment ratio (%) in Pre-primary schools?
Offer a very short reply. 97.03. What is the difference between the highest and the lowest Gross enrolment ratio (%) of Primary schools?
Offer a terse response. 105.24. What is the difference between the highest and the lowest Gross enrolment ratio (%) in Secondary schools?
Your answer should be very brief. 61.54. What is the difference between the highest and the lowest Gross enrolment ratio (%) in Tertiary schools?
Ensure brevity in your answer.  5.9. 